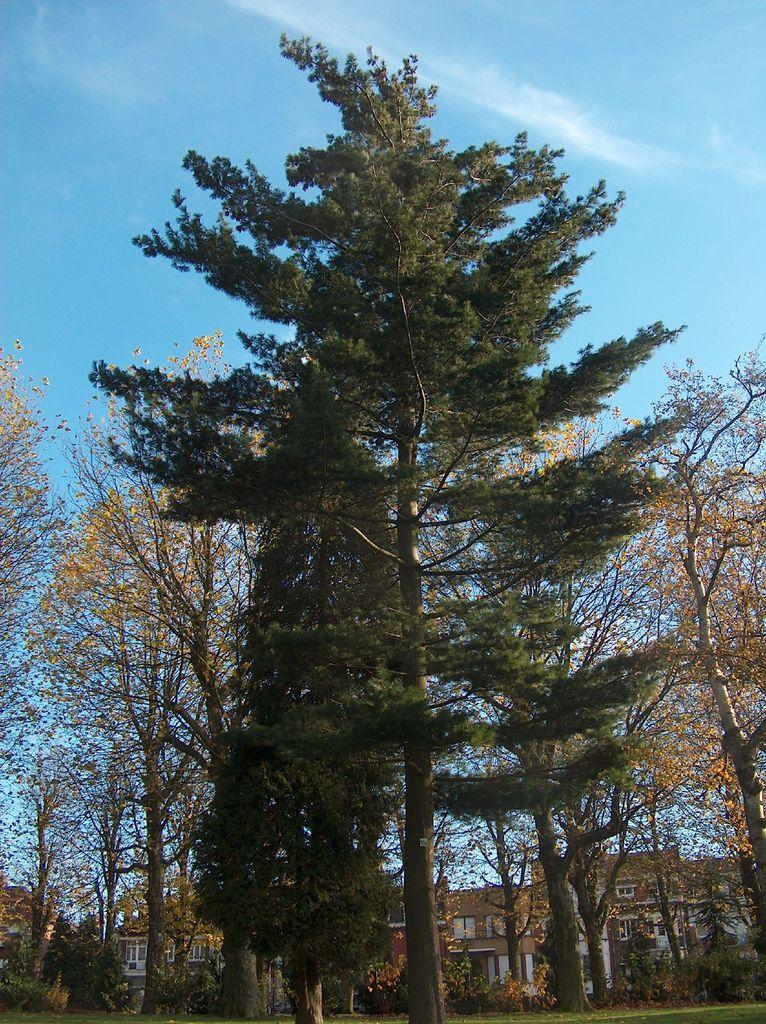What is the main subject in the foreground of the image? There is a big tree in the foreground of the image. What can be seen in the background of the image? The sky is visible in the background of the image. What type of discussion is taking place in the image? There is no discussion present in the image; it features a big tree and the sky. Can you tell me how many tanks are visible in the image? There are no tanks present in the image. 